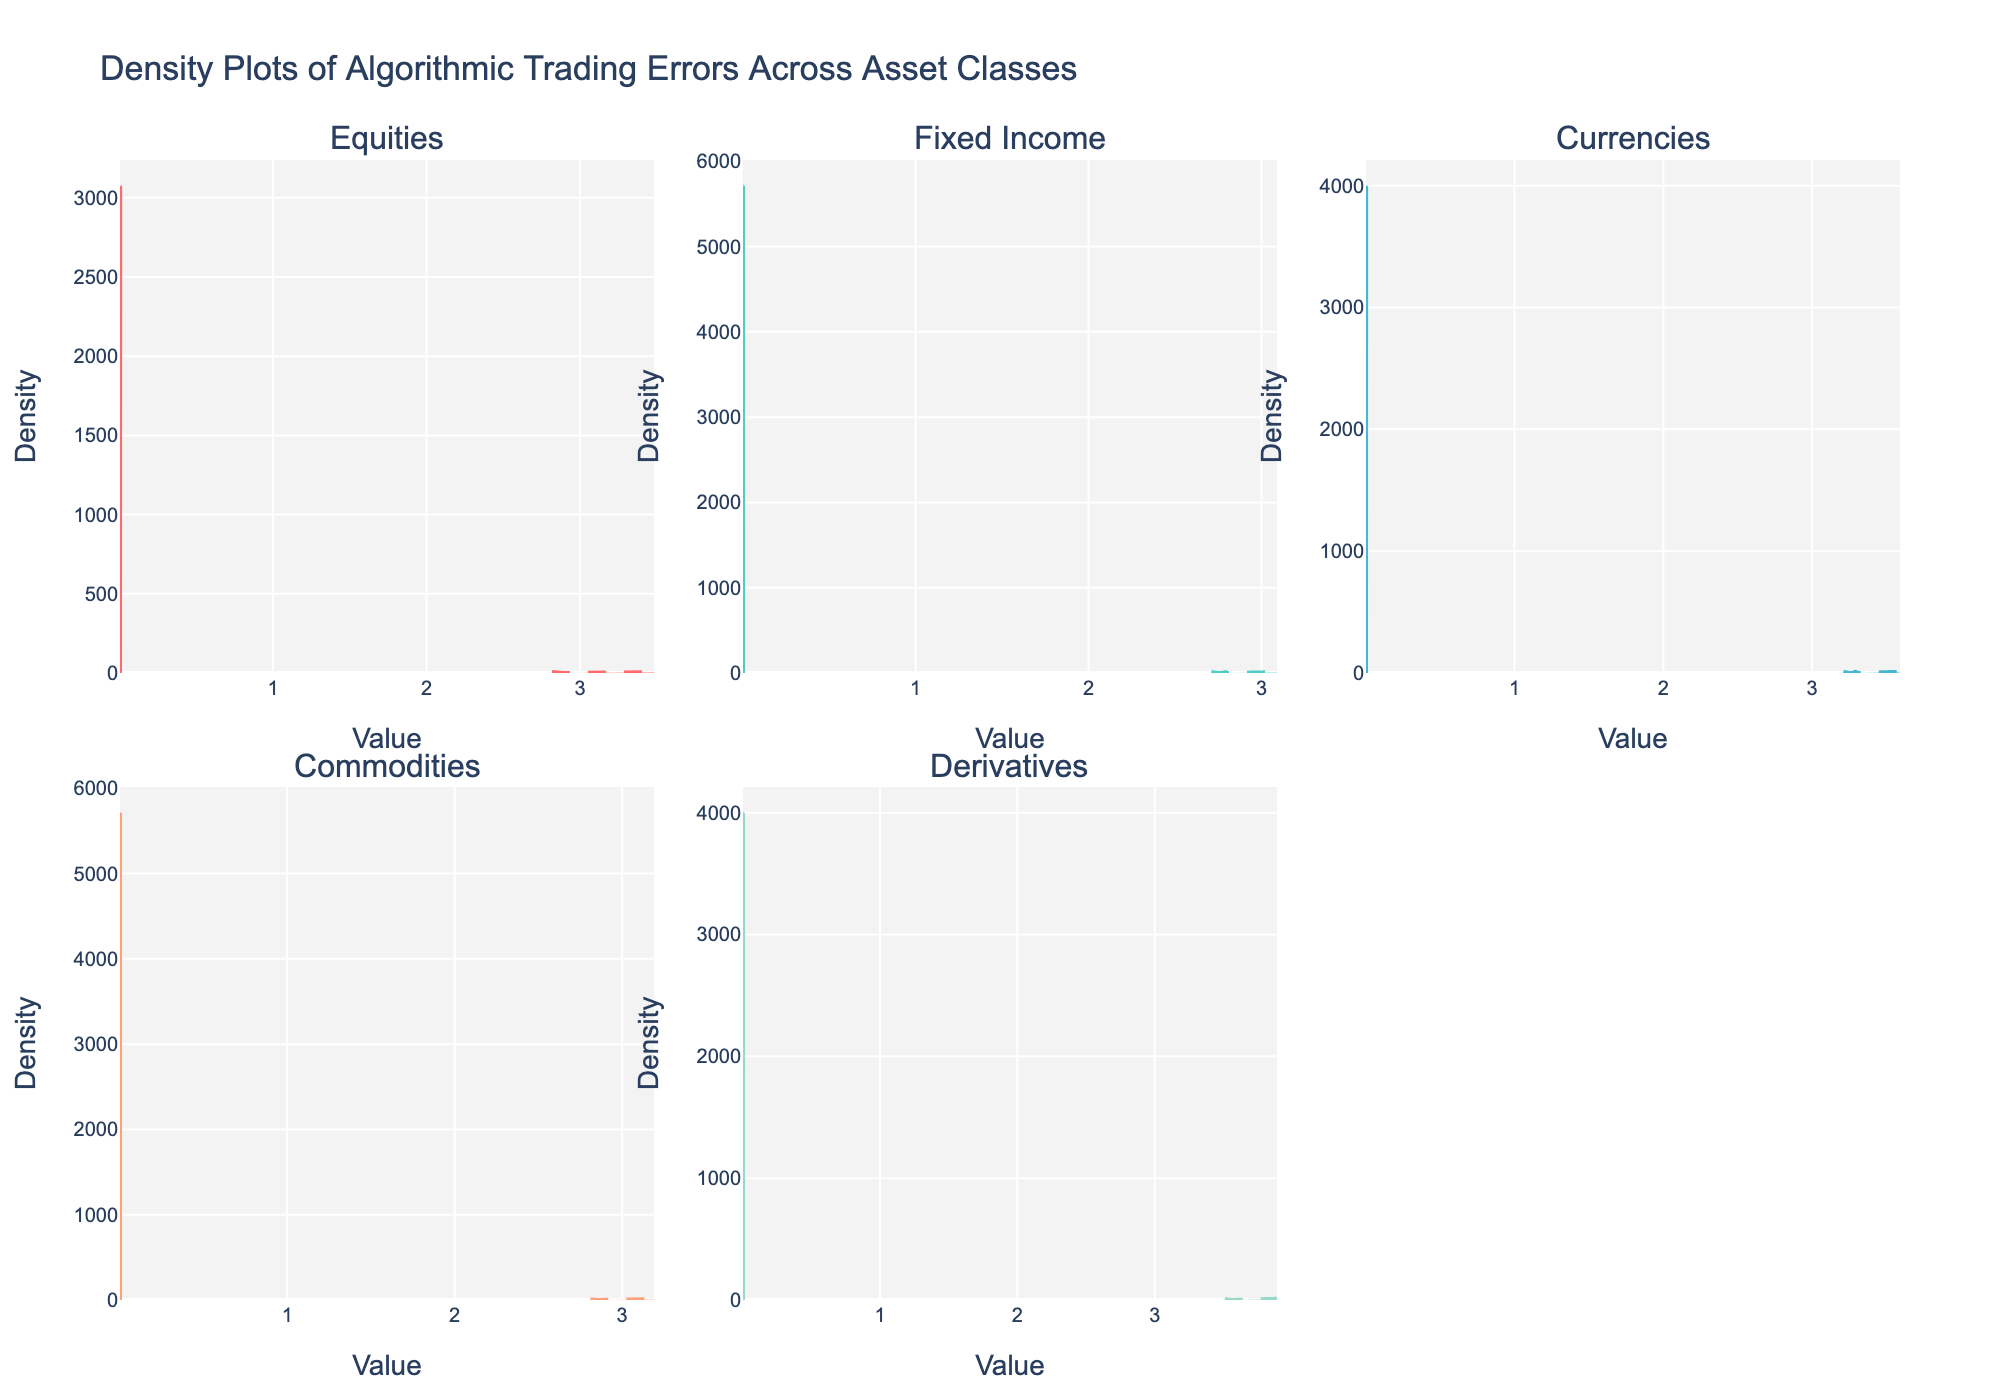What is the title of the figure? The title is located at the top of the figure and it reads "Density Plots of Algorithmic Trading Errors Across Asset Classes".
Answer: Density Plots of Algorithmic Trading Errors Across Asset Classes Which asset class has the highest peak in density for error frequency? By examining the density plots for error frequency, we can see that Derivatives have the highest peak density value for error frequency.
Answer: Derivatives How do the densities of error severity for Equities and Currencies compare visually? To compare densities visually, look at the density plots for severity of both Equities and Currencies. The Currencies error severity density is slightly higher and more spread out compared to Equities.
Answer: Currencies are slightly higher and more spread out What are the x-axis and y-axis titles for the density plots? The x-axis title appears as 'Value' and the y-axis title appears as 'Density' for each of the subplots.
Answer: Value and Density Which asset classes show density plots with two distinct peaks for any measurement? Looking at the figure, Fixed Income shows two distinct peaks for error severity, while none of the asset classes show two distinct peaks for error frequency.
Answer: Fixed Income (for error severity) Which asset class has the most similar density curves for both error frequency and severity? Observing both density plots (for frequency and severity) for each asset class, Currencies have quite similar curves.
Answer: Currencies What seems to be the range of error frequencies for Commodities? Visual inspection of the density plots in the Commodities subplot shows that the error frequency values range from approximately 0.0015 to 0.0025.
Answer: 0.0015 to 0.0025 Is the peak density of error frequency greater or smaller than the peak density of error severity for Fixed Income? The peak density of error frequency is smaller than the peak density of error severity for Fixed Income, as seen in the corresponding plots.
Answer: Smaller Which asset class exhibits the highest density for error severity? The density plot for error severity of derivatives shows the highest peak among all, indicating derivatives have the highest density for error severity.
Answer: Derivatives How are the density plots visually represented in terms of line style? The density plots for error frequency use solid lines, whereas the density plots for error severity use dashed lines for visual distinction.
Answer: Solid for error frequency, dashed for error severity 